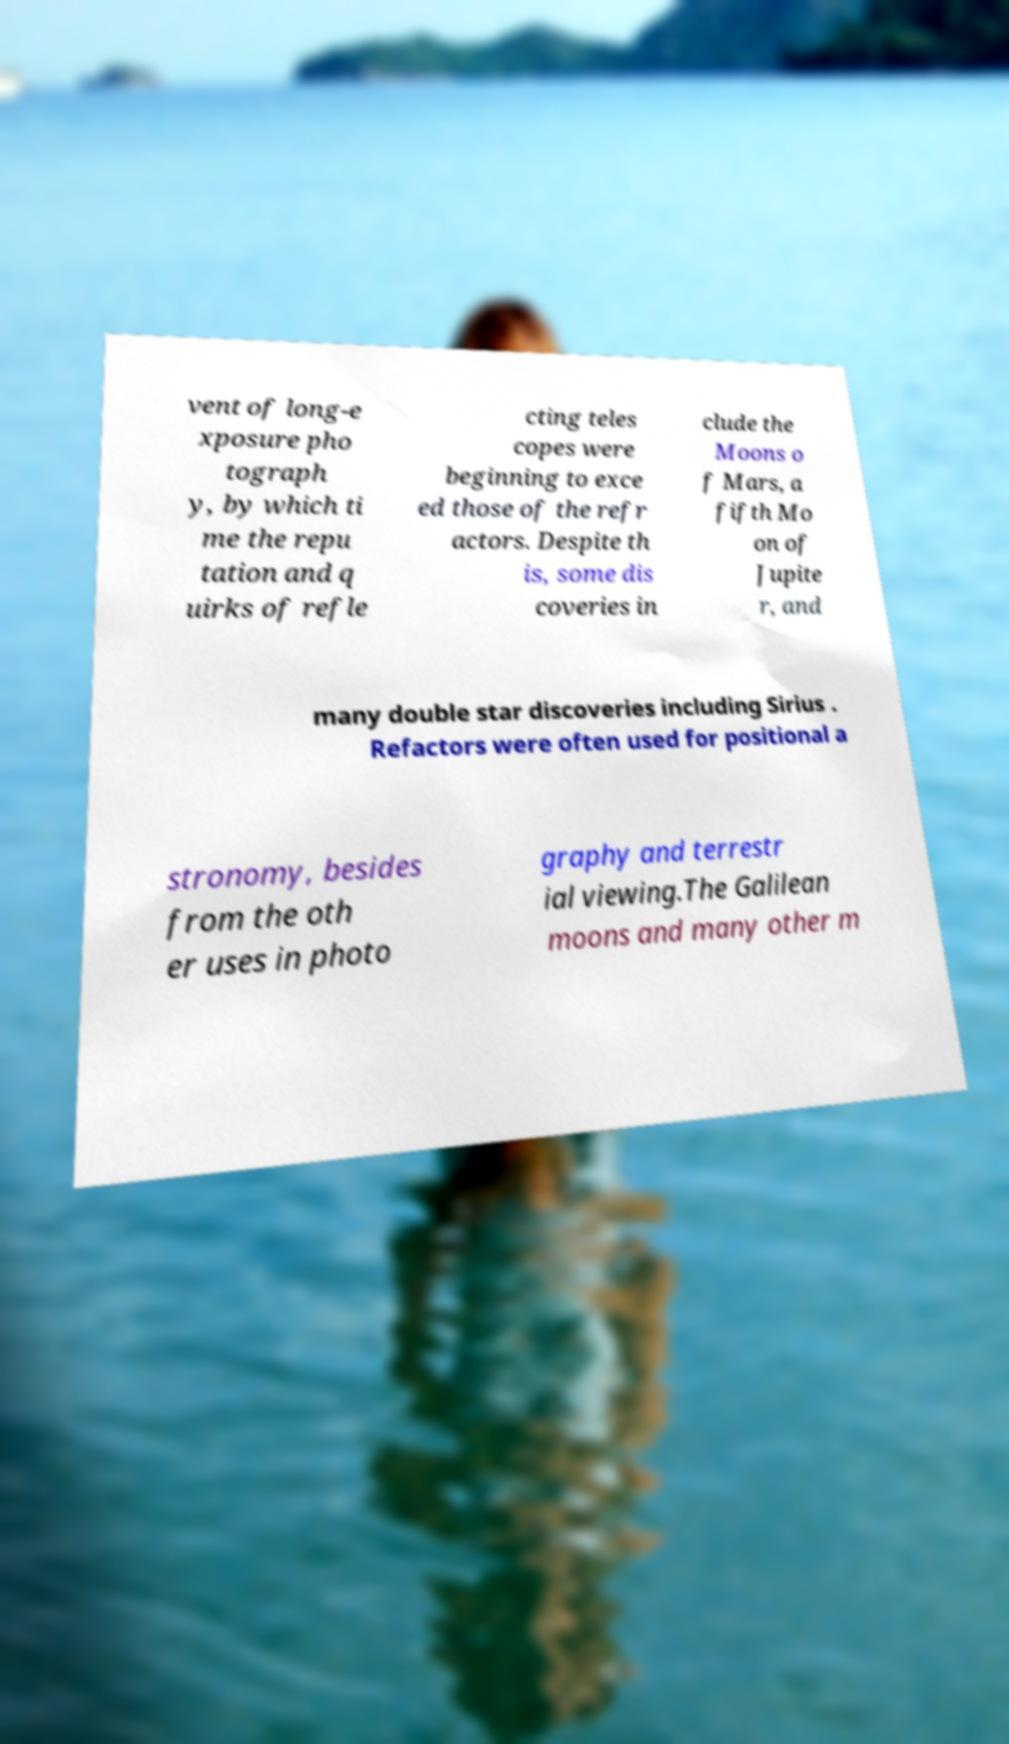For documentation purposes, I need the text within this image transcribed. Could you provide that? vent of long-e xposure pho tograph y, by which ti me the repu tation and q uirks of refle cting teles copes were beginning to exce ed those of the refr actors. Despite th is, some dis coveries in clude the Moons o f Mars, a fifth Mo on of Jupite r, and many double star discoveries including Sirius . Refactors were often used for positional a stronomy, besides from the oth er uses in photo graphy and terrestr ial viewing.The Galilean moons and many other m 